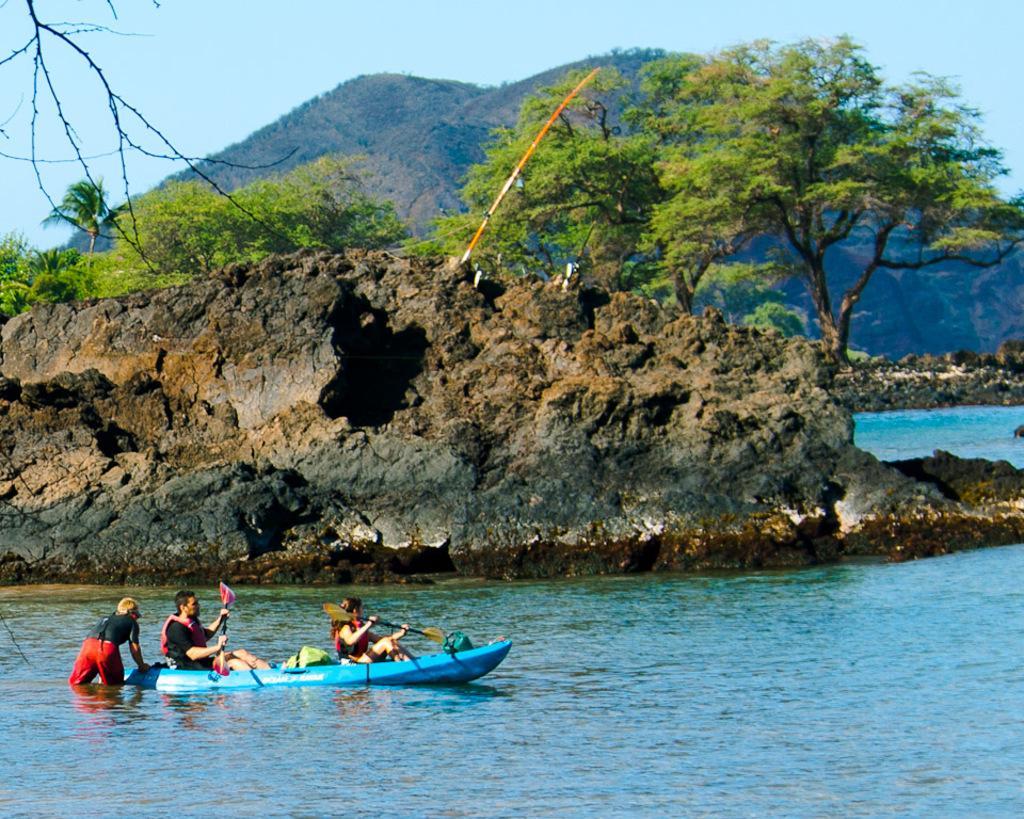In one or two sentences, can you explain what this image depicts? In this image, we can see a hill in the water. There are two persons on the boat which is floating on the water. There are trees in front of the hill. There is a sky at the top of the image. 